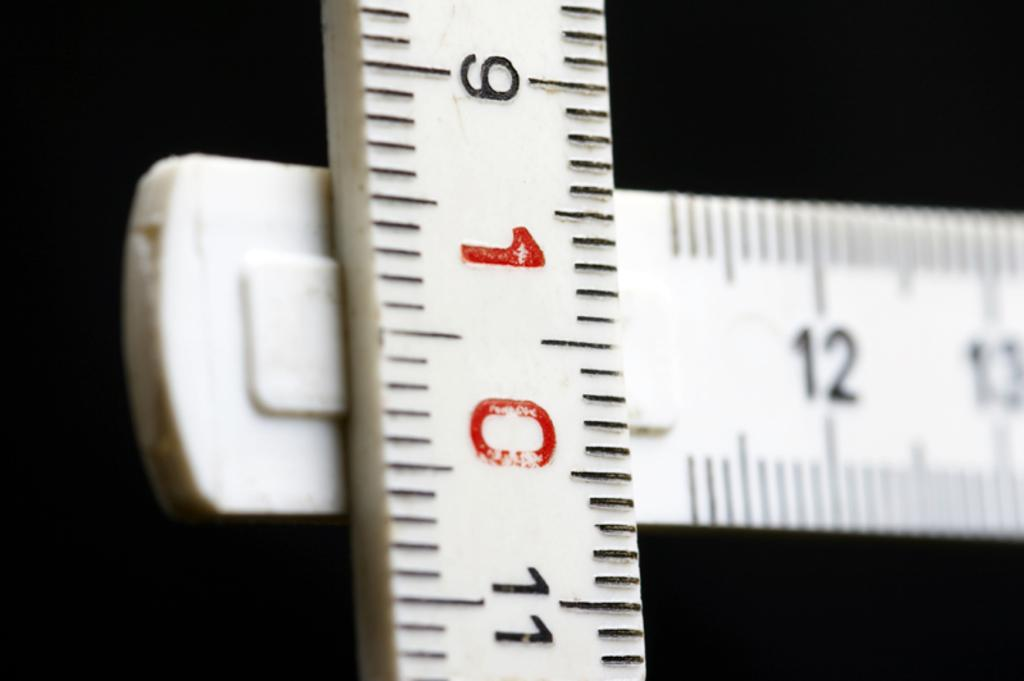<image>
Create a compact narrative representing the image presented. a white ruler T-square displaying 12 and 10 inches 